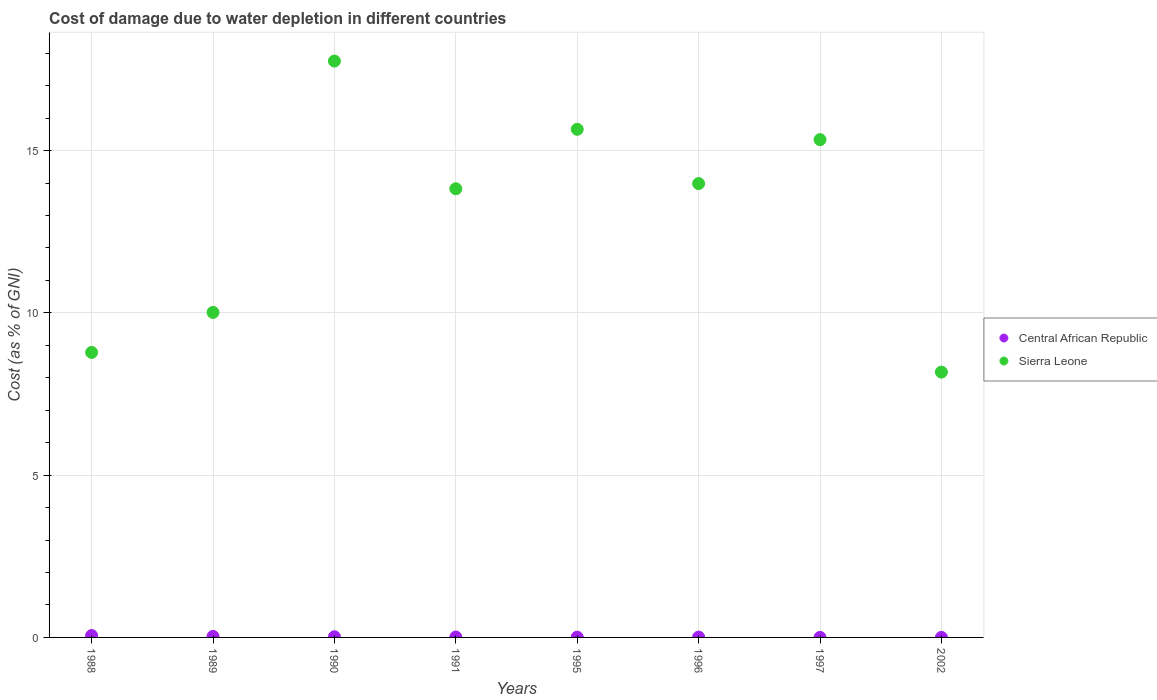How many different coloured dotlines are there?
Offer a very short reply. 2. Is the number of dotlines equal to the number of legend labels?
Your answer should be very brief. Yes. What is the cost of damage caused due to water depletion in Central African Republic in 1996?
Your answer should be very brief. 0.01. Across all years, what is the maximum cost of damage caused due to water depletion in Central African Republic?
Provide a succinct answer. 0.06. Across all years, what is the minimum cost of damage caused due to water depletion in Central African Republic?
Your answer should be compact. 0. What is the total cost of damage caused due to water depletion in Central African Republic in the graph?
Your response must be concise. 0.14. What is the difference between the cost of damage caused due to water depletion in Central African Republic in 1996 and that in 1997?
Make the answer very short. 0.01. What is the difference between the cost of damage caused due to water depletion in Central African Republic in 1988 and the cost of damage caused due to water depletion in Sierra Leone in 1996?
Provide a short and direct response. -13.92. What is the average cost of damage caused due to water depletion in Sierra Leone per year?
Ensure brevity in your answer.  12.94. In the year 2002, what is the difference between the cost of damage caused due to water depletion in Sierra Leone and cost of damage caused due to water depletion in Central African Republic?
Give a very brief answer. 8.17. What is the ratio of the cost of damage caused due to water depletion in Central African Republic in 1989 to that in 1997?
Keep it short and to the point. 33.32. Is the cost of damage caused due to water depletion in Sierra Leone in 1988 less than that in 2002?
Offer a very short reply. No. Is the difference between the cost of damage caused due to water depletion in Sierra Leone in 1996 and 1997 greater than the difference between the cost of damage caused due to water depletion in Central African Republic in 1996 and 1997?
Your answer should be compact. No. What is the difference between the highest and the second highest cost of damage caused due to water depletion in Central African Republic?
Give a very brief answer. 0.03. What is the difference between the highest and the lowest cost of damage caused due to water depletion in Sierra Leone?
Make the answer very short. 9.58. Is the sum of the cost of damage caused due to water depletion in Central African Republic in 1988 and 1997 greater than the maximum cost of damage caused due to water depletion in Sierra Leone across all years?
Provide a succinct answer. No. Does the cost of damage caused due to water depletion in Central African Republic monotonically increase over the years?
Your answer should be compact. No. How many dotlines are there?
Provide a succinct answer. 2. How many years are there in the graph?
Your response must be concise. 8. What is the difference between two consecutive major ticks on the Y-axis?
Ensure brevity in your answer.  5. Are the values on the major ticks of Y-axis written in scientific E-notation?
Provide a short and direct response. No. Does the graph contain grids?
Your response must be concise. Yes. How many legend labels are there?
Keep it short and to the point. 2. What is the title of the graph?
Keep it short and to the point. Cost of damage due to water depletion in different countries. What is the label or title of the Y-axis?
Provide a succinct answer. Cost (as % of GNI). What is the Cost (as % of GNI) of Central African Republic in 1988?
Your response must be concise. 0.06. What is the Cost (as % of GNI) in Sierra Leone in 1988?
Your response must be concise. 8.78. What is the Cost (as % of GNI) of Central African Republic in 1989?
Your answer should be very brief. 0.03. What is the Cost (as % of GNI) of Sierra Leone in 1989?
Provide a succinct answer. 10.01. What is the Cost (as % of GNI) of Central African Republic in 1990?
Provide a succinct answer. 0.02. What is the Cost (as % of GNI) of Sierra Leone in 1990?
Provide a short and direct response. 17.76. What is the Cost (as % of GNI) in Central African Republic in 1991?
Make the answer very short. 0.01. What is the Cost (as % of GNI) of Sierra Leone in 1991?
Your response must be concise. 13.82. What is the Cost (as % of GNI) in Central African Republic in 1995?
Make the answer very short. 0.01. What is the Cost (as % of GNI) of Sierra Leone in 1995?
Your answer should be compact. 15.65. What is the Cost (as % of GNI) of Central African Republic in 1996?
Your answer should be very brief. 0.01. What is the Cost (as % of GNI) of Sierra Leone in 1996?
Keep it short and to the point. 13.98. What is the Cost (as % of GNI) of Central African Republic in 1997?
Make the answer very short. 0. What is the Cost (as % of GNI) of Sierra Leone in 1997?
Give a very brief answer. 15.34. What is the Cost (as % of GNI) of Central African Republic in 2002?
Your answer should be very brief. 0. What is the Cost (as % of GNI) of Sierra Leone in 2002?
Provide a succinct answer. 8.17. Across all years, what is the maximum Cost (as % of GNI) in Central African Republic?
Ensure brevity in your answer.  0.06. Across all years, what is the maximum Cost (as % of GNI) in Sierra Leone?
Your answer should be very brief. 17.76. Across all years, what is the minimum Cost (as % of GNI) of Central African Republic?
Provide a succinct answer. 0. Across all years, what is the minimum Cost (as % of GNI) in Sierra Leone?
Provide a succinct answer. 8.17. What is the total Cost (as % of GNI) in Central African Republic in the graph?
Offer a very short reply. 0.14. What is the total Cost (as % of GNI) of Sierra Leone in the graph?
Make the answer very short. 103.52. What is the difference between the Cost (as % of GNI) of Central African Republic in 1988 and that in 1989?
Provide a succinct answer. 0.03. What is the difference between the Cost (as % of GNI) of Sierra Leone in 1988 and that in 1989?
Your response must be concise. -1.23. What is the difference between the Cost (as % of GNI) in Central African Republic in 1988 and that in 1990?
Your response must be concise. 0.04. What is the difference between the Cost (as % of GNI) of Sierra Leone in 1988 and that in 1990?
Make the answer very short. -8.98. What is the difference between the Cost (as % of GNI) of Central African Republic in 1988 and that in 1991?
Provide a short and direct response. 0.05. What is the difference between the Cost (as % of GNI) in Sierra Leone in 1988 and that in 1991?
Give a very brief answer. -5.04. What is the difference between the Cost (as % of GNI) of Central African Republic in 1988 and that in 1995?
Provide a short and direct response. 0.05. What is the difference between the Cost (as % of GNI) in Sierra Leone in 1988 and that in 1995?
Your answer should be compact. -6.87. What is the difference between the Cost (as % of GNI) in Central African Republic in 1988 and that in 1996?
Offer a terse response. 0.05. What is the difference between the Cost (as % of GNI) of Sierra Leone in 1988 and that in 1996?
Your answer should be compact. -5.2. What is the difference between the Cost (as % of GNI) in Central African Republic in 1988 and that in 1997?
Provide a short and direct response. 0.06. What is the difference between the Cost (as % of GNI) of Sierra Leone in 1988 and that in 1997?
Make the answer very short. -6.55. What is the difference between the Cost (as % of GNI) in Central African Republic in 1988 and that in 2002?
Your answer should be compact. 0.06. What is the difference between the Cost (as % of GNI) of Sierra Leone in 1988 and that in 2002?
Provide a short and direct response. 0.61. What is the difference between the Cost (as % of GNI) of Central African Republic in 1989 and that in 1990?
Offer a terse response. 0.01. What is the difference between the Cost (as % of GNI) of Sierra Leone in 1989 and that in 1990?
Give a very brief answer. -7.74. What is the difference between the Cost (as % of GNI) of Central African Republic in 1989 and that in 1991?
Your answer should be compact. 0.02. What is the difference between the Cost (as % of GNI) of Sierra Leone in 1989 and that in 1991?
Your answer should be very brief. -3.81. What is the difference between the Cost (as % of GNI) of Central African Republic in 1989 and that in 1995?
Ensure brevity in your answer.  0.02. What is the difference between the Cost (as % of GNI) of Sierra Leone in 1989 and that in 1995?
Keep it short and to the point. -5.64. What is the difference between the Cost (as % of GNI) of Central African Republic in 1989 and that in 1996?
Offer a terse response. 0.02. What is the difference between the Cost (as % of GNI) of Sierra Leone in 1989 and that in 1996?
Give a very brief answer. -3.97. What is the difference between the Cost (as % of GNI) of Central African Republic in 1989 and that in 1997?
Give a very brief answer. 0.03. What is the difference between the Cost (as % of GNI) of Sierra Leone in 1989 and that in 1997?
Give a very brief answer. -5.32. What is the difference between the Cost (as % of GNI) in Central African Republic in 1989 and that in 2002?
Give a very brief answer. 0.03. What is the difference between the Cost (as % of GNI) of Sierra Leone in 1989 and that in 2002?
Your answer should be compact. 1.84. What is the difference between the Cost (as % of GNI) in Central African Republic in 1990 and that in 1991?
Make the answer very short. 0.01. What is the difference between the Cost (as % of GNI) in Sierra Leone in 1990 and that in 1991?
Provide a succinct answer. 3.93. What is the difference between the Cost (as % of GNI) in Central African Republic in 1990 and that in 1995?
Make the answer very short. 0.01. What is the difference between the Cost (as % of GNI) in Sierra Leone in 1990 and that in 1995?
Your answer should be very brief. 2.1. What is the difference between the Cost (as % of GNI) in Central African Republic in 1990 and that in 1996?
Your answer should be compact. 0.01. What is the difference between the Cost (as % of GNI) in Sierra Leone in 1990 and that in 1996?
Give a very brief answer. 3.77. What is the difference between the Cost (as % of GNI) in Central African Republic in 1990 and that in 1997?
Offer a terse response. 0.02. What is the difference between the Cost (as % of GNI) in Sierra Leone in 1990 and that in 1997?
Ensure brevity in your answer.  2.42. What is the difference between the Cost (as % of GNI) of Central African Republic in 1990 and that in 2002?
Give a very brief answer. 0.02. What is the difference between the Cost (as % of GNI) of Sierra Leone in 1990 and that in 2002?
Make the answer very short. 9.58. What is the difference between the Cost (as % of GNI) of Central African Republic in 1991 and that in 1995?
Offer a terse response. 0.01. What is the difference between the Cost (as % of GNI) in Sierra Leone in 1991 and that in 1995?
Keep it short and to the point. -1.83. What is the difference between the Cost (as % of GNI) of Central African Republic in 1991 and that in 1996?
Make the answer very short. 0. What is the difference between the Cost (as % of GNI) of Sierra Leone in 1991 and that in 1996?
Give a very brief answer. -0.16. What is the difference between the Cost (as % of GNI) of Central African Republic in 1991 and that in 1997?
Provide a succinct answer. 0.01. What is the difference between the Cost (as % of GNI) in Sierra Leone in 1991 and that in 1997?
Provide a succinct answer. -1.51. What is the difference between the Cost (as % of GNI) in Central African Republic in 1991 and that in 2002?
Keep it short and to the point. 0.01. What is the difference between the Cost (as % of GNI) of Sierra Leone in 1991 and that in 2002?
Provide a succinct answer. 5.65. What is the difference between the Cost (as % of GNI) in Central African Republic in 1995 and that in 1996?
Your response must be concise. -0. What is the difference between the Cost (as % of GNI) of Sierra Leone in 1995 and that in 1996?
Your answer should be very brief. 1.67. What is the difference between the Cost (as % of GNI) of Central African Republic in 1995 and that in 1997?
Make the answer very short. 0.01. What is the difference between the Cost (as % of GNI) of Sierra Leone in 1995 and that in 1997?
Provide a short and direct response. 0.32. What is the difference between the Cost (as % of GNI) of Central African Republic in 1995 and that in 2002?
Keep it short and to the point. 0.01. What is the difference between the Cost (as % of GNI) of Sierra Leone in 1995 and that in 2002?
Your answer should be compact. 7.48. What is the difference between the Cost (as % of GNI) of Central African Republic in 1996 and that in 1997?
Offer a terse response. 0.01. What is the difference between the Cost (as % of GNI) in Sierra Leone in 1996 and that in 1997?
Provide a short and direct response. -1.35. What is the difference between the Cost (as % of GNI) in Central African Republic in 1996 and that in 2002?
Keep it short and to the point. 0.01. What is the difference between the Cost (as % of GNI) of Sierra Leone in 1996 and that in 2002?
Your answer should be compact. 5.81. What is the difference between the Cost (as % of GNI) of Central African Republic in 1997 and that in 2002?
Ensure brevity in your answer.  -0. What is the difference between the Cost (as % of GNI) in Sierra Leone in 1997 and that in 2002?
Provide a succinct answer. 7.16. What is the difference between the Cost (as % of GNI) in Central African Republic in 1988 and the Cost (as % of GNI) in Sierra Leone in 1989?
Ensure brevity in your answer.  -9.95. What is the difference between the Cost (as % of GNI) of Central African Republic in 1988 and the Cost (as % of GNI) of Sierra Leone in 1990?
Provide a succinct answer. -17.7. What is the difference between the Cost (as % of GNI) in Central African Republic in 1988 and the Cost (as % of GNI) in Sierra Leone in 1991?
Offer a terse response. -13.76. What is the difference between the Cost (as % of GNI) in Central African Republic in 1988 and the Cost (as % of GNI) in Sierra Leone in 1995?
Offer a very short reply. -15.6. What is the difference between the Cost (as % of GNI) of Central African Republic in 1988 and the Cost (as % of GNI) of Sierra Leone in 1996?
Keep it short and to the point. -13.92. What is the difference between the Cost (as % of GNI) of Central African Republic in 1988 and the Cost (as % of GNI) of Sierra Leone in 1997?
Your answer should be very brief. -15.28. What is the difference between the Cost (as % of GNI) of Central African Republic in 1988 and the Cost (as % of GNI) of Sierra Leone in 2002?
Ensure brevity in your answer.  -8.12. What is the difference between the Cost (as % of GNI) of Central African Republic in 1989 and the Cost (as % of GNI) of Sierra Leone in 1990?
Give a very brief answer. -17.73. What is the difference between the Cost (as % of GNI) of Central African Republic in 1989 and the Cost (as % of GNI) of Sierra Leone in 1991?
Your answer should be compact. -13.79. What is the difference between the Cost (as % of GNI) in Central African Republic in 1989 and the Cost (as % of GNI) in Sierra Leone in 1995?
Offer a terse response. -15.62. What is the difference between the Cost (as % of GNI) of Central African Republic in 1989 and the Cost (as % of GNI) of Sierra Leone in 1996?
Your response must be concise. -13.95. What is the difference between the Cost (as % of GNI) of Central African Republic in 1989 and the Cost (as % of GNI) of Sierra Leone in 1997?
Offer a very short reply. -15.3. What is the difference between the Cost (as % of GNI) of Central African Republic in 1989 and the Cost (as % of GNI) of Sierra Leone in 2002?
Keep it short and to the point. -8.14. What is the difference between the Cost (as % of GNI) in Central African Republic in 1990 and the Cost (as % of GNI) in Sierra Leone in 1991?
Give a very brief answer. -13.8. What is the difference between the Cost (as % of GNI) of Central African Republic in 1990 and the Cost (as % of GNI) of Sierra Leone in 1995?
Make the answer very short. -15.63. What is the difference between the Cost (as % of GNI) in Central African Republic in 1990 and the Cost (as % of GNI) in Sierra Leone in 1996?
Provide a succinct answer. -13.96. What is the difference between the Cost (as % of GNI) of Central African Republic in 1990 and the Cost (as % of GNI) of Sierra Leone in 1997?
Ensure brevity in your answer.  -15.31. What is the difference between the Cost (as % of GNI) in Central African Republic in 1990 and the Cost (as % of GNI) in Sierra Leone in 2002?
Offer a terse response. -8.15. What is the difference between the Cost (as % of GNI) of Central African Republic in 1991 and the Cost (as % of GNI) of Sierra Leone in 1995?
Your response must be concise. -15.64. What is the difference between the Cost (as % of GNI) of Central African Republic in 1991 and the Cost (as % of GNI) of Sierra Leone in 1996?
Your answer should be very brief. -13.97. What is the difference between the Cost (as % of GNI) of Central African Republic in 1991 and the Cost (as % of GNI) of Sierra Leone in 1997?
Offer a terse response. -15.32. What is the difference between the Cost (as % of GNI) in Central African Republic in 1991 and the Cost (as % of GNI) in Sierra Leone in 2002?
Your answer should be very brief. -8.16. What is the difference between the Cost (as % of GNI) in Central African Republic in 1995 and the Cost (as % of GNI) in Sierra Leone in 1996?
Provide a succinct answer. -13.98. What is the difference between the Cost (as % of GNI) in Central African Republic in 1995 and the Cost (as % of GNI) in Sierra Leone in 1997?
Your answer should be very brief. -15.33. What is the difference between the Cost (as % of GNI) of Central African Republic in 1995 and the Cost (as % of GNI) of Sierra Leone in 2002?
Give a very brief answer. -8.17. What is the difference between the Cost (as % of GNI) in Central African Republic in 1996 and the Cost (as % of GNI) in Sierra Leone in 1997?
Your response must be concise. -15.33. What is the difference between the Cost (as % of GNI) in Central African Republic in 1996 and the Cost (as % of GNI) in Sierra Leone in 2002?
Provide a short and direct response. -8.16. What is the difference between the Cost (as % of GNI) in Central African Republic in 1997 and the Cost (as % of GNI) in Sierra Leone in 2002?
Offer a terse response. -8.17. What is the average Cost (as % of GNI) in Central African Republic per year?
Provide a short and direct response. 0.02. What is the average Cost (as % of GNI) in Sierra Leone per year?
Keep it short and to the point. 12.94. In the year 1988, what is the difference between the Cost (as % of GNI) of Central African Republic and Cost (as % of GNI) of Sierra Leone?
Your answer should be very brief. -8.72. In the year 1989, what is the difference between the Cost (as % of GNI) of Central African Republic and Cost (as % of GNI) of Sierra Leone?
Provide a succinct answer. -9.98. In the year 1990, what is the difference between the Cost (as % of GNI) of Central African Republic and Cost (as % of GNI) of Sierra Leone?
Keep it short and to the point. -17.74. In the year 1991, what is the difference between the Cost (as % of GNI) in Central African Republic and Cost (as % of GNI) in Sierra Leone?
Keep it short and to the point. -13.81. In the year 1995, what is the difference between the Cost (as % of GNI) in Central African Republic and Cost (as % of GNI) in Sierra Leone?
Make the answer very short. -15.65. In the year 1996, what is the difference between the Cost (as % of GNI) in Central African Republic and Cost (as % of GNI) in Sierra Leone?
Provide a short and direct response. -13.97. In the year 1997, what is the difference between the Cost (as % of GNI) of Central African Republic and Cost (as % of GNI) of Sierra Leone?
Offer a very short reply. -15.33. In the year 2002, what is the difference between the Cost (as % of GNI) in Central African Republic and Cost (as % of GNI) in Sierra Leone?
Give a very brief answer. -8.17. What is the ratio of the Cost (as % of GNI) in Central African Republic in 1988 to that in 1989?
Provide a succinct answer. 1.92. What is the ratio of the Cost (as % of GNI) of Sierra Leone in 1988 to that in 1989?
Provide a succinct answer. 0.88. What is the ratio of the Cost (as % of GNI) of Central African Republic in 1988 to that in 1990?
Give a very brief answer. 2.81. What is the ratio of the Cost (as % of GNI) of Sierra Leone in 1988 to that in 1990?
Your answer should be compact. 0.49. What is the ratio of the Cost (as % of GNI) of Central African Republic in 1988 to that in 1991?
Give a very brief answer. 4.6. What is the ratio of the Cost (as % of GNI) in Sierra Leone in 1988 to that in 1991?
Offer a terse response. 0.64. What is the ratio of the Cost (as % of GNI) in Central African Republic in 1988 to that in 1995?
Your answer should be compact. 8.11. What is the ratio of the Cost (as % of GNI) in Sierra Leone in 1988 to that in 1995?
Offer a terse response. 0.56. What is the ratio of the Cost (as % of GNI) in Central African Republic in 1988 to that in 1996?
Give a very brief answer. 6.06. What is the ratio of the Cost (as % of GNI) in Sierra Leone in 1988 to that in 1996?
Give a very brief answer. 0.63. What is the ratio of the Cost (as % of GNI) in Central African Republic in 1988 to that in 1997?
Keep it short and to the point. 64.01. What is the ratio of the Cost (as % of GNI) in Sierra Leone in 1988 to that in 1997?
Your response must be concise. 0.57. What is the ratio of the Cost (as % of GNI) in Central African Republic in 1988 to that in 2002?
Your answer should be compact. 42.87. What is the ratio of the Cost (as % of GNI) in Sierra Leone in 1988 to that in 2002?
Your answer should be very brief. 1.07. What is the ratio of the Cost (as % of GNI) in Central African Republic in 1989 to that in 1990?
Your answer should be compact. 1.46. What is the ratio of the Cost (as % of GNI) in Sierra Leone in 1989 to that in 1990?
Give a very brief answer. 0.56. What is the ratio of the Cost (as % of GNI) in Central African Republic in 1989 to that in 1991?
Your answer should be compact. 2.4. What is the ratio of the Cost (as % of GNI) in Sierra Leone in 1989 to that in 1991?
Ensure brevity in your answer.  0.72. What is the ratio of the Cost (as % of GNI) of Central African Republic in 1989 to that in 1995?
Your answer should be compact. 4.22. What is the ratio of the Cost (as % of GNI) of Sierra Leone in 1989 to that in 1995?
Your response must be concise. 0.64. What is the ratio of the Cost (as % of GNI) of Central African Republic in 1989 to that in 1996?
Your answer should be compact. 3.16. What is the ratio of the Cost (as % of GNI) in Sierra Leone in 1989 to that in 1996?
Provide a succinct answer. 0.72. What is the ratio of the Cost (as % of GNI) of Central African Republic in 1989 to that in 1997?
Ensure brevity in your answer.  33.32. What is the ratio of the Cost (as % of GNI) in Sierra Leone in 1989 to that in 1997?
Ensure brevity in your answer.  0.65. What is the ratio of the Cost (as % of GNI) in Central African Republic in 1989 to that in 2002?
Offer a very short reply. 22.32. What is the ratio of the Cost (as % of GNI) of Sierra Leone in 1989 to that in 2002?
Your answer should be compact. 1.23. What is the ratio of the Cost (as % of GNI) of Central African Republic in 1990 to that in 1991?
Make the answer very short. 1.64. What is the ratio of the Cost (as % of GNI) in Sierra Leone in 1990 to that in 1991?
Provide a short and direct response. 1.28. What is the ratio of the Cost (as % of GNI) of Central African Republic in 1990 to that in 1995?
Ensure brevity in your answer.  2.89. What is the ratio of the Cost (as % of GNI) in Sierra Leone in 1990 to that in 1995?
Your answer should be compact. 1.13. What is the ratio of the Cost (as % of GNI) of Central African Republic in 1990 to that in 1996?
Provide a short and direct response. 2.16. What is the ratio of the Cost (as % of GNI) of Sierra Leone in 1990 to that in 1996?
Make the answer very short. 1.27. What is the ratio of the Cost (as % of GNI) in Central African Republic in 1990 to that in 1997?
Offer a terse response. 22.79. What is the ratio of the Cost (as % of GNI) of Sierra Leone in 1990 to that in 1997?
Give a very brief answer. 1.16. What is the ratio of the Cost (as % of GNI) in Central African Republic in 1990 to that in 2002?
Your response must be concise. 15.27. What is the ratio of the Cost (as % of GNI) in Sierra Leone in 1990 to that in 2002?
Offer a very short reply. 2.17. What is the ratio of the Cost (as % of GNI) in Central African Republic in 1991 to that in 1995?
Offer a very short reply. 1.76. What is the ratio of the Cost (as % of GNI) of Sierra Leone in 1991 to that in 1995?
Keep it short and to the point. 0.88. What is the ratio of the Cost (as % of GNI) of Central African Republic in 1991 to that in 1996?
Your answer should be compact. 1.32. What is the ratio of the Cost (as % of GNI) of Sierra Leone in 1991 to that in 1996?
Make the answer very short. 0.99. What is the ratio of the Cost (as % of GNI) of Central African Republic in 1991 to that in 1997?
Your answer should be very brief. 13.9. What is the ratio of the Cost (as % of GNI) of Sierra Leone in 1991 to that in 1997?
Ensure brevity in your answer.  0.9. What is the ratio of the Cost (as % of GNI) in Central African Republic in 1991 to that in 2002?
Provide a succinct answer. 9.31. What is the ratio of the Cost (as % of GNI) of Sierra Leone in 1991 to that in 2002?
Your answer should be very brief. 1.69. What is the ratio of the Cost (as % of GNI) in Central African Republic in 1995 to that in 1996?
Ensure brevity in your answer.  0.75. What is the ratio of the Cost (as % of GNI) in Sierra Leone in 1995 to that in 1996?
Your answer should be very brief. 1.12. What is the ratio of the Cost (as % of GNI) in Central African Republic in 1995 to that in 1997?
Ensure brevity in your answer.  7.89. What is the ratio of the Cost (as % of GNI) of Sierra Leone in 1995 to that in 1997?
Make the answer very short. 1.02. What is the ratio of the Cost (as % of GNI) of Central African Republic in 1995 to that in 2002?
Keep it short and to the point. 5.29. What is the ratio of the Cost (as % of GNI) in Sierra Leone in 1995 to that in 2002?
Make the answer very short. 1.92. What is the ratio of the Cost (as % of GNI) of Central African Republic in 1996 to that in 1997?
Your answer should be very brief. 10.56. What is the ratio of the Cost (as % of GNI) in Sierra Leone in 1996 to that in 1997?
Provide a succinct answer. 0.91. What is the ratio of the Cost (as % of GNI) of Central African Republic in 1996 to that in 2002?
Your response must be concise. 7.07. What is the ratio of the Cost (as % of GNI) of Sierra Leone in 1996 to that in 2002?
Provide a short and direct response. 1.71. What is the ratio of the Cost (as % of GNI) in Central African Republic in 1997 to that in 2002?
Give a very brief answer. 0.67. What is the ratio of the Cost (as % of GNI) of Sierra Leone in 1997 to that in 2002?
Offer a terse response. 1.88. What is the difference between the highest and the second highest Cost (as % of GNI) in Central African Republic?
Offer a terse response. 0.03. What is the difference between the highest and the second highest Cost (as % of GNI) of Sierra Leone?
Offer a terse response. 2.1. What is the difference between the highest and the lowest Cost (as % of GNI) of Central African Republic?
Ensure brevity in your answer.  0.06. What is the difference between the highest and the lowest Cost (as % of GNI) of Sierra Leone?
Your answer should be very brief. 9.58. 